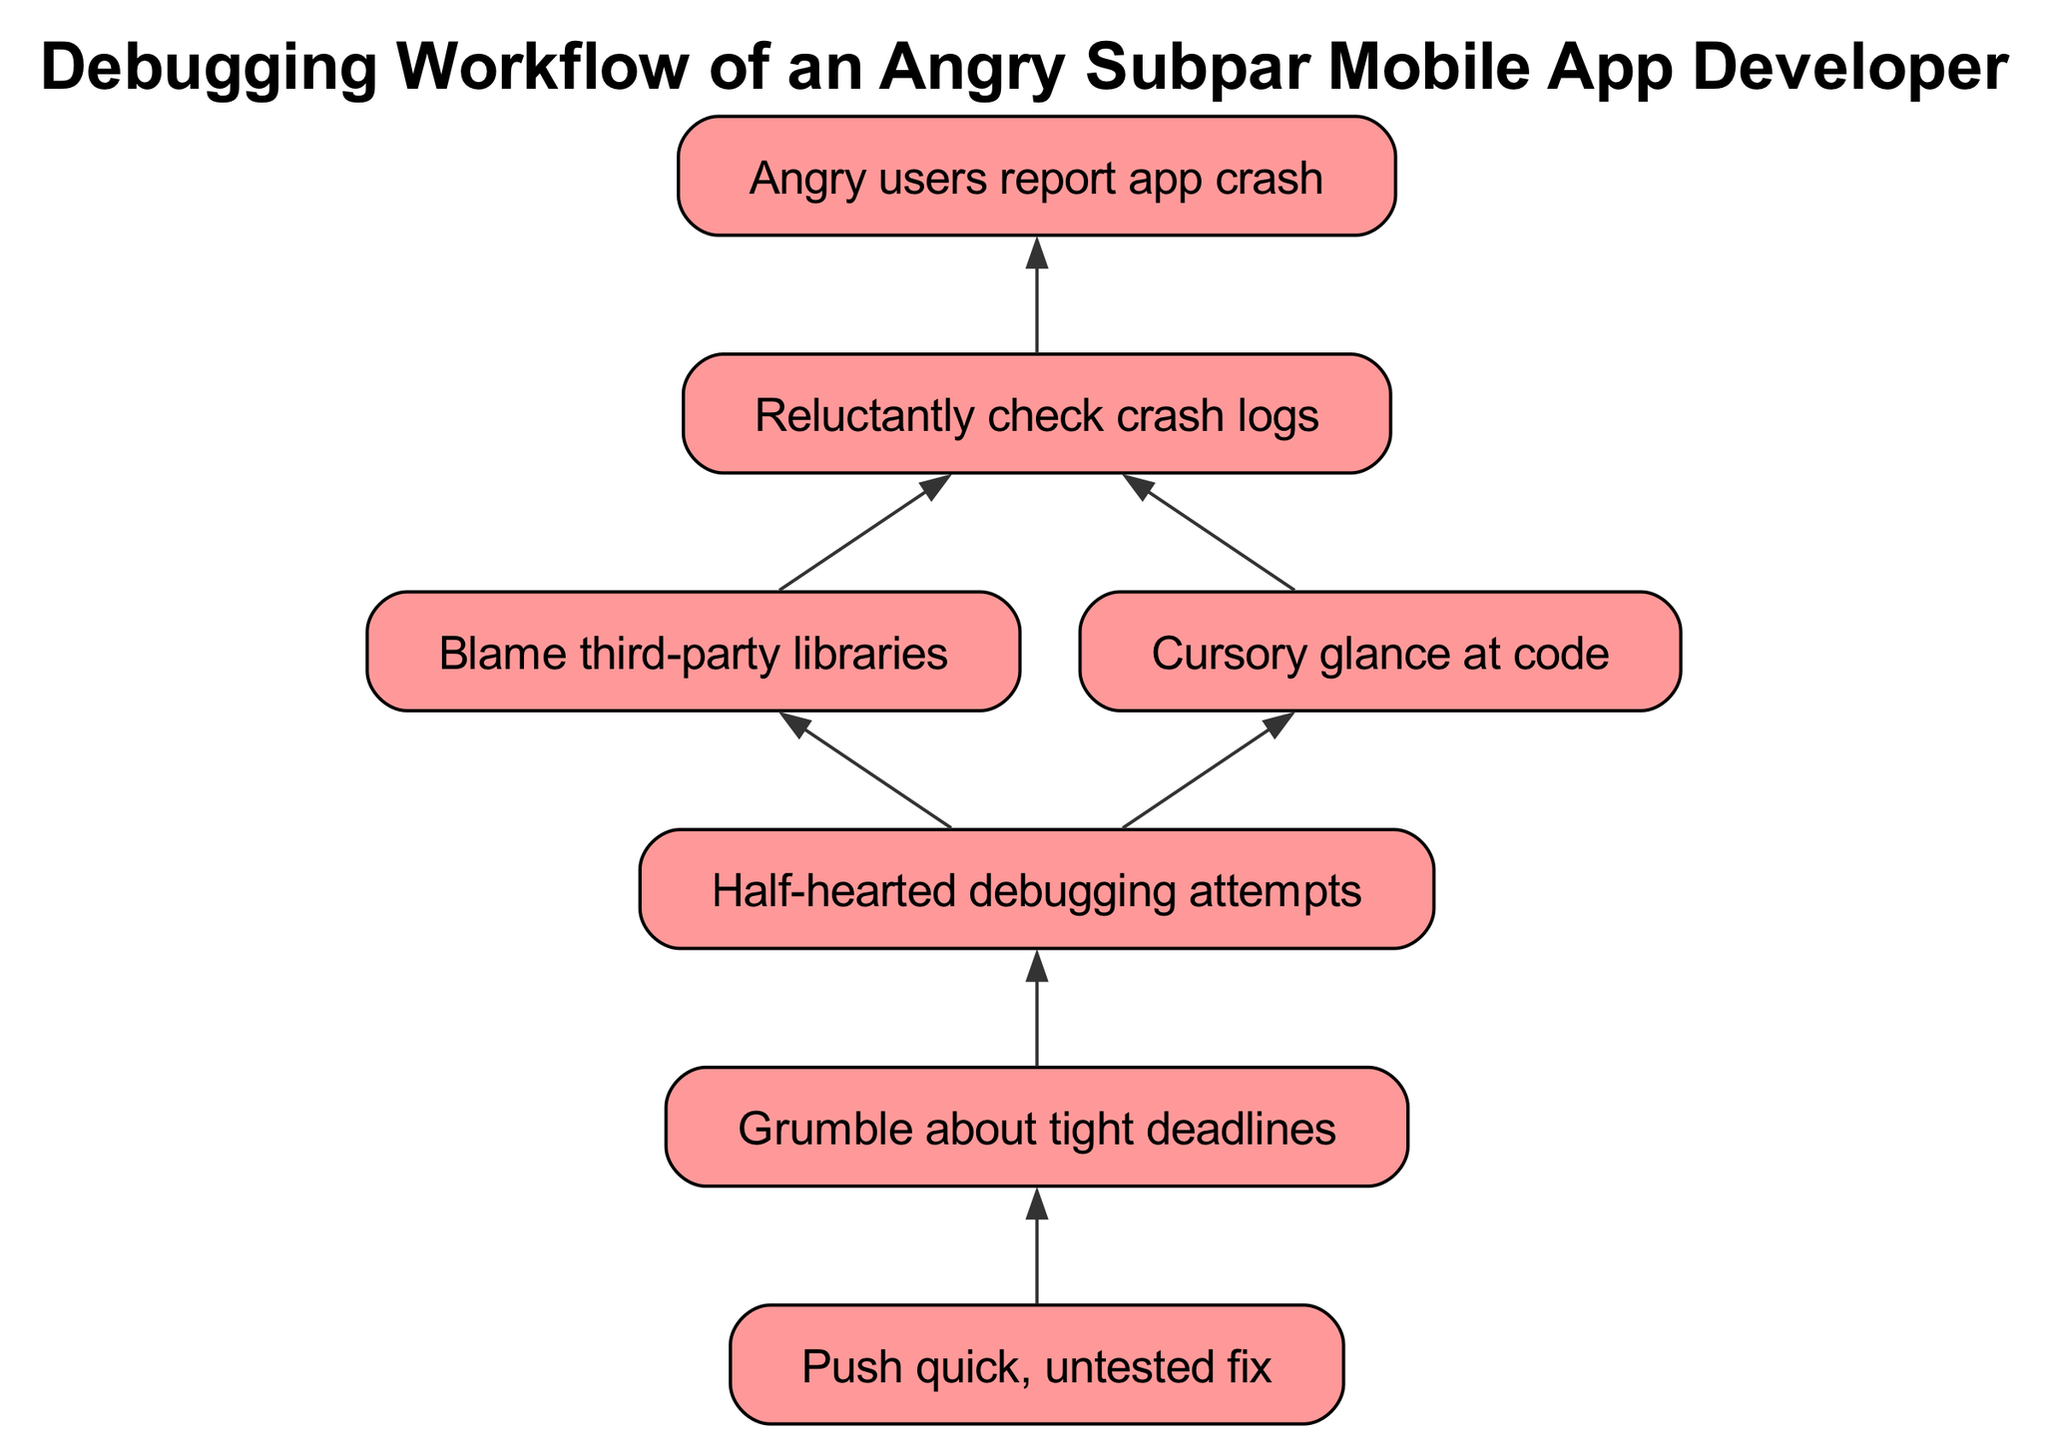What's the first step in the debugging workflow? The first step according to the diagram is "Angry users report app crash," which serves as the starting point in the debugging process shown in the flow chart.
Answer: Angry users report app crash How many nodes are present in the diagram? By counting all the individual elements listed, there are a total of 7 nodes in the diagram representing different steps in the debugging workflow.
Answer: 7 Which node follows after checking crash logs? The next node that follows "Reluctantly check crash logs" can be either "Blame third-party libraries" or "Cursory glance at code," as these nodes are directly connected to the second node.
Answer: Blame third-party libraries, Cursory glance at code What is the final node of the debugging workflow? The last node in the flow, showing the final step of the debugging workflow, is "Push quick, untested fix." This node has no outgoing connections, indicating it is the endpoint of the process.
Answer: Push quick, untested fix What connections lead to half-hearted debugging attempts? The nodes that lead to "Half-hearted debugging attempts" are "Blame third-party libraries" and "Cursory glance at code." These two steps indicate what precedes the debugging attempts according to the flow.
Answer: Blame third-party libraries, Cursory glance at code If users report crashes and the developer blames third-party libraries, what is the next course of action? If the crash logs are checked and the developer blames third-party libraries, the workflow indicates that the next action would be "Half-hearted debugging attempts," as it directly follows both preceding options.
Answer: Half-hearted debugging attempts What is the relationship between pushing quick, untested fixes and tight deadlines? According to the diagram, "Grumble about tight deadlines" precedes "Push quick, untested fix," indicating that the pressure of deadlines impacts the decision to implement fixes without thorough testing.
Answer: Push quick, untested fix How many connections are there leading from the 'Reluctantly check crash logs' node? The 'Reluctantly check crash logs' node has two outgoing connections leading to "Blame third-party libraries" and "Cursory glance at code," making the total number of connections from this node equal to 2.
Answer: 2 Which node reflects the frustration of the developer? The node "Grumble about tight deadlines" explicitly indicates the frustration of the developer, conveying the impact of time constraints on the debugging process.
Answer: Grumble about tight deadlines 